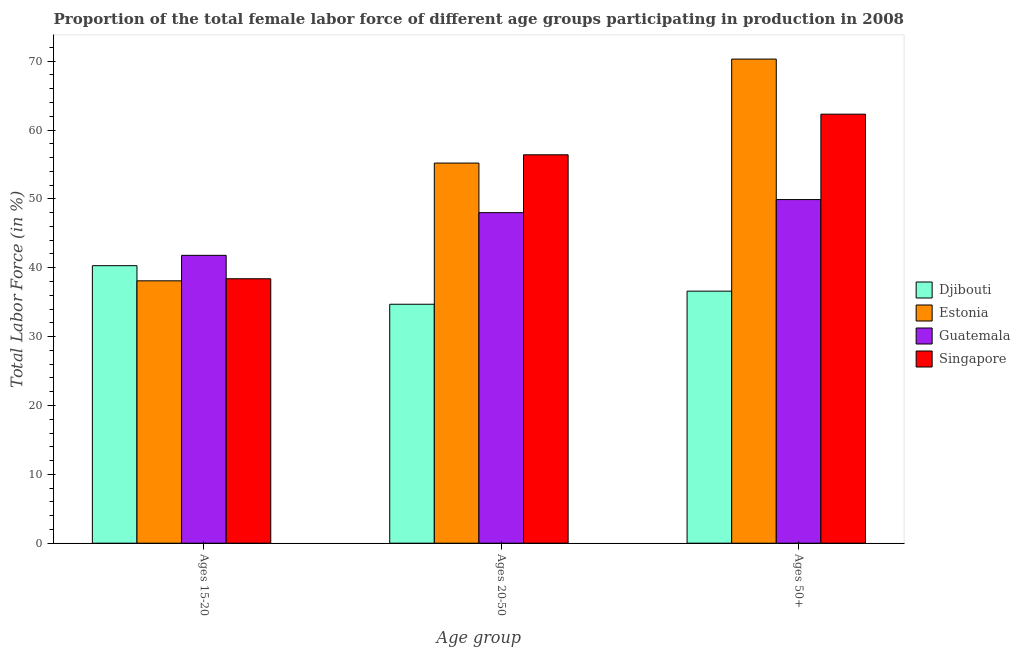Are the number of bars per tick equal to the number of legend labels?
Your response must be concise. Yes. How many bars are there on the 2nd tick from the left?
Your answer should be compact. 4. What is the label of the 1st group of bars from the left?
Ensure brevity in your answer.  Ages 15-20. What is the percentage of female labor force within the age group 20-50 in Djibouti?
Provide a short and direct response. 34.7. Across all countries, what is the maximum percentage of female labor force above age 50?
Give a very brief answer. 70.3. Across all countries, what is the minimum percentage of female labor force within the age group 20-50?
Offer a very short reply. 34.7. In which country was the percentage of female labor force above age 50 maximum?
Provide a short and direct response. Estonia. In which country was the percentage of female labor force within the age group 20-50 minimum?
Keep it short and to the point. Djibouti. What is the total percentage of female labor force above age 50 in the graph?
Keep it short and to the point. 219.1. What is the difference between the percentage of female labor force within the age group 15-20 in Djibouti and that in Guatemala?
Provide a short and direct response. -1.5. What is the difference between the percentage of female labor force within the age group 15-20 in Djibouti and the percentage of female labor force within the age group 20-50 in Guatemala?
Ensure brevity in your answer.  -7.7. What is the average percentage of female labor force within the age group 15-20 per country?
Ensure brevity in your answer.  39.65. What is the difference between the percentage of female labor force within the age group 15-20 and percentage of female labor force within the age group 20-50 in Djibouti?
Provide a succinct answer. 5.6. What is the ratio of the percentage of female labor force within the age group 15-20 in Estonia to that in Guatemala?
Make the answer very short. 0.91. Is the percentage of female labor force within the age group 20-50 in Singapore less than that in Estonia?
Your response must be concise. No. Is the difference between the percentage of female labor force above age 50 in Guatemala and Estonia greater than the difference between the percentage of female labor force within the age group 15-20 in Guatemala and Estonia?
Give a very brief answer. No. What is the difference between the highest and the second highest percentage of female labor force within the age group 15-20?
Make the answer very short. 1.5. What is the difference between the highest and the lowest percentage of female labor force within the age group 20-50?
Provide a short and direct response. 21.7. In how many countries, is the percentage of female labor force above age 50 greater than the average percentage of female labor force above age 50 taken over all countries?
Offer a very short reply. 2. What does the 1st bar from the left in Ages 20-50 represents?
Offer a very short reply. Djibouti. What does the 3rd bar from the right in Ages 50+ represents?
Your answer should be very brief. Estonia. Are all the bars in the graph horizontal?
Offer a terse response. No. What is the difference between two consecutive major ticks on the Y-axis?
Your answer should be compact. 10. Does the graph contain any zero values?
Your answer should be compact. No. Does the graph contain grids?
Give a very brief answer. No. How many legend labels are there?
Provide a succinct answer. 4. How are the legend labels stacked?
Offer a very short reply. Vertical. What is the title of the graph?
Ensure brevity in your answer.  Proportion of the total female labor force of different age groups participating in production in 2008. Does "United Arab Emirates" appear as one of the legend labels in the graph?
Keep it short and to the point. No. What is the label or title of the X-axis?
Your answer should be compact. Age group. What is the label or title of the Y-axis?
Ensure brevity in your answer.  Total Labor Force (in %). What is the Total Labor Force (in %) in Djibouti in Ages 15-20?
Give a very brief answer. 40.3. What is the Total Labor Force (in %) in Estonia in Ages 15-20?
Make the answer very short. 38.1. What is the Total Labor Force (in %) of Guatemala in Ages 15-20?
Offer a very short reply. 41.8. What is the Total Labor Force (in %) in Singapore in Ages 15-20?
Provide a succinct answer. 38.4. What is the Total Labor Force (in %) in Djibouti in Ages 20-50?
Your answer should be very brief. 34.7. What is the Total Labor Force (in %) in Estonia in Ages 20-50?
Offer a terse response. 55.2. What is the Total Labor Force (in %) in Guatemala in Ages 20-50?
Your answer should be compact. 48. What is the Total Labor Force (in %) in Singapore in Ages 20-50?
Give a very brief answer. 56.4. What is the Total Labor Force (in %) in Djibouti in Ages 50+?
Offer a terse response. 36.6. What is the Total Labor Force (in %) of Estonia in Ages 50+?
Your answer should be very brief. 70.3. What is the Total Labor Force (in %) in Guatemala in Ages 50+?
Your response must be concise. 49.9. What is the Total Labor Force (in %) of Singapore in Ages 50+?
Your answer should be compact. 62.3. Across all Age group, what is the maximum Total Labor Force (in %) in Djibouti?
Your response must be concise. 40.3. Across all Age group, what is the maximum Total Labor Force (in %) in Estonia?
Your answer should be compact. 70.3. Across all Age group, what is the maximum Total Labor Force (in %) of Guatemala?
Ensure brevity in your answer.  49.9. Across all Age group, what is the maximum Total Labor Force (in %) of Singapore?
Provide a short and direct response. 62.3. Across all Age group, what is the minimum Total Labor Force (in %) of Djibouti?
Your response must be concise. 34.7. Across all Age group, what is the minimum Total Labor Force (in %) of Estonia?
Give a very brief answer. 38.1. Across all Age group, what is the minimum Total Labor Force (in %) in Guatemala?
Provide a short and direct response. 41.8. Across all Age group, what is the minimum Total Labor Force (in %) in Singapore?
Provide a succinct answer. 38.4. What is the total Total Labor Force (in %) of Djibouti in the graph?
Keep it short and to the point. 111.6. What is the total Total Labor Force (in %) in Estonia in the graph?
Your answer should be compact. 163.6. What is the total Total Labor Force (in %) of Guatemala in the graph?
Keep it short and to the point. 139.7. What is the total Total Labor Force (in %) in Singapore in the graph?
Offer a terse response. 157.1. What is the difference between the Total Labor Force (in %) in Djibouti in Ages 15-20 and that in Ages 20-50?
Your response must be concise. 5.6. What is the difference between the Total Labor Force (in %) in Estonia in Ages 15-20 and that in Ages 20-50?
Keep it short and to the point. -17.1. What is the difference between the Total Labor Force (in %) of Guatemala in Ages 15-20 and that in Ages 20-50?
Give a very brief answer. -6.2. What is the difference between the Total Labor Force (in %) of Singapore in Ages 15-20 and that in Ages 20-50?
Your response must be concise. -18. What is the difference between the Total Labor Force (in %) in Estonia in Ages 15-20 and that in Ages 50+?
Offer a very short reply. -32.2. What is the difference between the Total Labor Force (in %) of Guatemala in Ages 15-20 and that in Ages 50+?
Your answer should be very brief. -8.1. What is the difference between the Total Labor Force (in %) in Singapore in Ages 15-20 and that in Ages 50+?
Make the answer very short. -23.9. What is the difference between the Total Labor Force (in %) of Estonia in Ages 20-50 and that in Ages 50+?
Your response must be concise. -15.1. What is the difference between the Total Labor Force (in %) in Singapore in Ages 20-50 and that in Ages 50+?
Your answer should be very brief. -5.9. What is the difference between the Total Labor Force (in %) of Djibouti in Ages 15-20 and the Total Labor Force (in %) of Estonia in Ages 20-50?
Provide a succinct answer. -14.9. What is the difference between the Total Labor Force (in %) of Djibouti in Ages 15-20 and the Total Labor Force (in %) of Guatemala in Ages 20-50?
Keep it short and to the point. -7.7. What is the difference between the Total Labor Force (in %) of Djibouti in Ages 15-20 and the Total Labor Force (in %) of Singapore in Ages 20-50?
Your answer should be very brief. -16.1. What is the difference between the Total Labor Force (in %) in Estonia in Ages 15-20 and the Total Labor Force (in %) in Guatemala in Ages 20-50?
Keep it short and to the point. -9.9. What is the difference between the Total Labor Force (in %) in Estonia in Ages 15-20 and the Total Labor Force (in %) in Singapore in Ages 20-50?
Keep it short and to the point. -18.3. What is the difference between the Total Labor Force (in %) in Guatemala in Ages 15-20 and the Total Labor Force (in %) in Singapore in Ages 20-50?
Provide a succinct answer. -14.6. What is the difference between the Total Labor Force (in %) in Djibouti in Ages 15-20 and the Total Labor Force (in %) in Guatemala in Ages 50+?
Make the answer very short. -9.6. What is the difference between the Total Labor Force (in %) in Estonia in Ages 15-20 and the Total Labor Force (in %) in Singapore in Ages 50+?
Your response must be concise. -24.2. What is the difference between the Total Labor Force (in %) of Guatemala in Ages 15-20 and the Total Labor Force (in %) of Singapore in Ages 50+?
Provide a short and direct response. -20.5. What is the difference between the Total Labor Force (in %) of Djibouti in Ages 20-50 and the Total Labor Force (in %) of Estonia in Ages 50+?
Provide a succinct answer. -35.6. What is the difference between the Total Labor Force (in %) of Djibouti in Ages 20-50 and the Total Labor Force (in %) of Guatemala in Ages 50+?
Give a very brief answer. -15.2. What is the difference between the Total Labor Force (in %) of Djibouti in Ages 20-50 and the Total Labor Force (in %) of Singapore in Ages 50+?
Give a very brief answer. -27.6. What is the difference between the Total Labor Force (in %) of Estonia in Ages 20-50 and the Total Labor Force (in %) of Guatemala in Ages 50+?
Make the answer very short. 5.3. What is the difference between the Total Labor Force (in %) in Estonia in Ages 20-50 and the Total Labor Force (in %) in Singapore in Ages 50+?
Make the answer very short. -7.1. What is the difference between the Total Labor Force (in %) in Guatemala in Ages 20-50 and the Total Labor Force (in %) in Singapore in Ages 50+?
Ensure brevity in your answer.  -14.3. What is the average Total Labor Force (in %) in Djibouti per Age group?
Keep it short and to the point. 37.2. What is the average Total Labor Force (in %) of Estonia per Age group?
Provide a succinct answer. 54.53. What is the average Total Labor Force (in %) in Guatemala per Age group?
Provide a succinct answer. 46.57. What is the average Total Labor Force (in %) in Singapore per Age group?
Ensure brevity in your answer.  52.37. What is the difference between the Total Labor Force (in %) of Djibouti and Total Labor Force (in %) of Estonia in Ages 15-20?
Your response must be concise. 2.2. What is the difference between the Total Labor Force (in %) in Djibouti and Total Labor Force (in %) in Singapore in Ages 15-20?
Provide a succinct answer. 1.9. What is the difference between the Total Labor Force (in %) of Estonia and Total Labor Force (in %) of Guatemala in Ages 15-20?
Make the answer very short. -3.7. What is the difference between the Total Labor Force (in %) in Estonia and Total Labor Force (in %) in Singapore in Ages 15-20?
Give a very brief answer. -0.3. What is the difference between the Total Labor Force (in %) of Guatemala and Total Labor Force (in %) of Singapore in Ages 15-20?
Provide a short and direct response. 3.4. What is the difference between the Total Labor Force (in %) of Djibouti and Total Labor Force (in %) of Estonia in Ages 20-50?
Your answer should be compact. -20.5. What is the difference between the Total Labor Force (in %) in Djibouti and Total Labor Force (in %) in Singapore in Ages 20-50?
Offer a terse response. -21.7. What is the difference between the Total Labor Force (in %) of Estonia and Total Labor Force (in %) of Guatemala in Ages 20-50?
Provide a succinct answer. 7.2. What is the difference between the Total Labor Force (in %) in Estonia and Total Labor Force (in %) in Singapore in Ages 20-50?
Your answer should be compact. -1.2. What is the difference between the Total Labor Force (in %) of Guatemala and Total Labor Force (in %) of Singapore in Ages 20-50?
Offer a terse response. -8.4. What is the difference between the Total Labor Force (in %) of Djibouti and Total Labor Force (in %) of Estonia in Ages 50+?
Your answer should be compact. -33.7. What is the difference between the Total Labor Force (in %) in Djibouti and Total Labor Force (in %) in Singapore in Ages 50+?
Your answer should be compact. -25.7. What is the difference between the Total Labor Force (in %) of Estonia and Total Labor Force (in %) of Guatemala in Ages 50+?
Provide a short and direct response. 20.4. What is the difference between the Total Labor Force (in %) of Estonia and Total Labor Force (in %) of Singapore in Ages 50+?
Offer a terse response. 8. What is the difference between the Total Labor Force (in %) of Guatemala and Total Labor Force (in %) of Singapore in Ages 50+?
Provide a short and direct response. -12.4. What is the ratio of the Total Labor Force (in %) of Djibouti in Ages 15-20 to that in Ages 20-50?
Make the answer very short. 1.16. What is the ratio of the Total Labor Force (in %) in Estonia in Ages 15-20 to that in Ages 20-50?
Your response must be concise. 0.69. What is the ratio of the Total Labor Force (in %) of Guatemala in Ages 15-20 to that in Ages 20-50?
Provide a short and direct response. 0.87. What is the ratio of the Total Labor Force (in %) of Singapore in Ages 15-20 to that in Ages 20-50?
Ensure brevity in your answer.  0.68. What is the ratio of the Total Labor Force (in %) in Djibouti in Ages 15-20 to that in Ages 50+?
Provide a short and direct response. 1.1. What is the ratio of the Total Labor Force (in %) in Estonia in Ages 15-20 to that in Ages 50+?
Ensure brevity in your answer.  0.54. What is the ratio of the Total Labor Force (in %) of Guatemala in Ages 15-20 to that in Ages 50+?
Give a very brief answer. 0.84. What is the ratio of the Total Labor Force (in %) of Singapore in Ages 15-20 to that in Ages 50+?
Ensure brevity in your answer.  0.62. What is the ratio of the Total Labor Force (in %) in Djibouti in Ages 20-50 to that in Ages 50+?
Offer a terse response. 0.95. What is the ratio of the Total Labor Force (in %) in Estonia in Ages 20-50 to that in Ages 50+?
Keep it short and to the point. 0.79. What is the ratio of the Total Labor Force (in %) of Guatemala in Ages 20-50 to that in Ages 50+?
Provide a short and direct response. 0.96. What is the ratio of the Total Labor Force (in %) of Singapore in Ages 20-50 to that in Ages 50+?
Offer a terse response. 0.91. What is the difference between the highest and the second highest Total Labor Force (in %) of Djibouti?
Provide a short and direct response. 3.7. What is the difference between the highest and the second highest Total Labor Force (in %) in Estonia?
Provide a short and direct response. 15.1. What is the difference between the highest and the lowest Total Labor Force (in %) of Djibouti?
Make the answer very short. 5.6. What is the difference between the highest and the lowest Total Labor Force (in %) in Estonia?
Offer a terse response. 32.2. What is the difference between the highest and the lowest Total Labor Force (in %) of Singapore?
Make the answer very short. 23.9. 